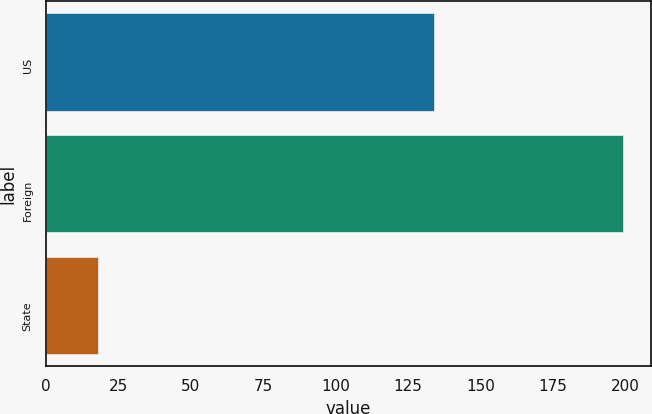<chart> <loc_0><loc_0><loc_500><loc_500><bar_chart><fcel>US<fcel>Foreign<fcel>State<nl><fcel>134<fcel>199<fcel>18<nl></chart> 